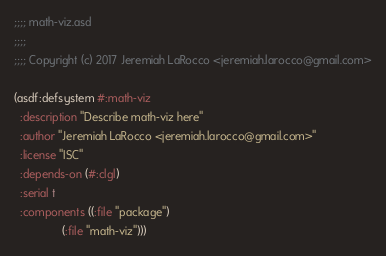Convert code to text. <code><loc_0><loc_0><loc_500><loc_500><_Lisp_>;;;; math-viz.asd
;;;;
;;;; Copyright (c) 2017 Jeremiah LaRocco <jeremiah.larocco@gmail.com>

(asdf:defsystem #:math-viz
  :description "Describe math-viz here"
  :author "Jeremiah LaRocco <jeremiah.larocco@gmail.com>"
  :license "ISC"
  :depends-on (#:clgl)
  :serial t
  :components ((:file "package")
               (:file "math-viz")))

</code> 